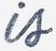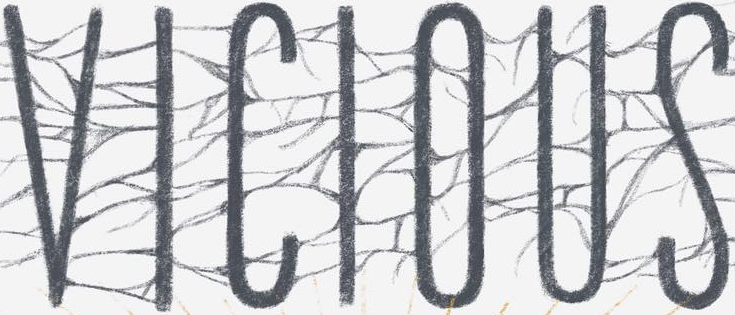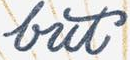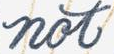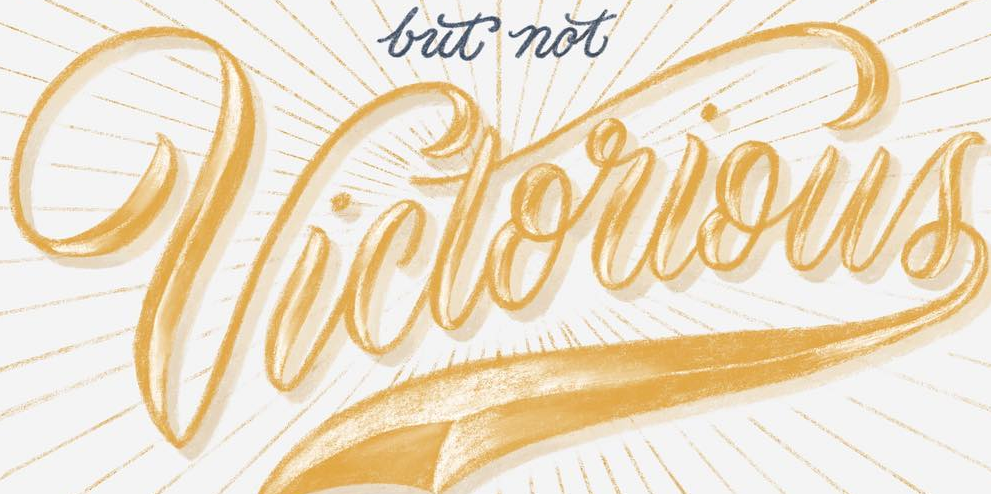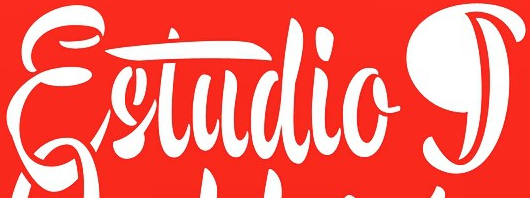Read the text content from these images in order, separated by a semicolon. is; VICIOUS; but; not; Victorious; Estudiog 